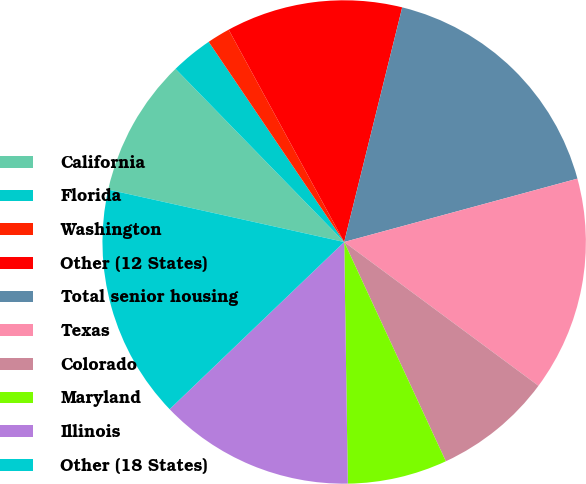<chart> <loc_0><loc_0><loc_500><loc_500><pie_chart><fcel>California<fcel>Florida<fcel>Washington<fcel>Other (12 States)<fcel>Total senior housing<fcel>Texas<fcel>Colorado<fcel>Maryland<fcel>Illinois<fcel>Other (18 States)<nl><fcel>9.23%<fcel>2.82%<fcel>1.54%<fcel>11.79%<fcel>16.92%<fcel>14.36%<fcel>7.95%<fcel>6.67%<fcel>13.08%<fcel>15.64%<nl></chart> 